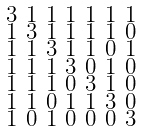<formula> <loc_0><loc_0><loc_500><loc_500>\begin{smallmatrix} 3 & 1 & 1 & 1 & 1 & 1 & 1 \\ 1 & 3 & 1 & 1 & 1 & 1 & 0 \\ 1 & 1 & 3 & 1 & 1 & 0 & 1 \\ 1 & 1 & 1 & 3 & 0 & 1 & 0 \\ 1 & 1 & 1 & 0 & 3 & 1 & 0 \\ 1 & 1 & 0 & 1 & 1 & 3 & 0 \\ 1 & 0 & 1 & 0 & 0 & 0 & 3 \end{smallmatrix}</formula> 